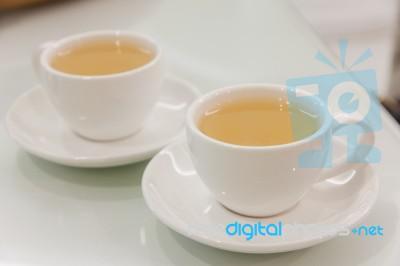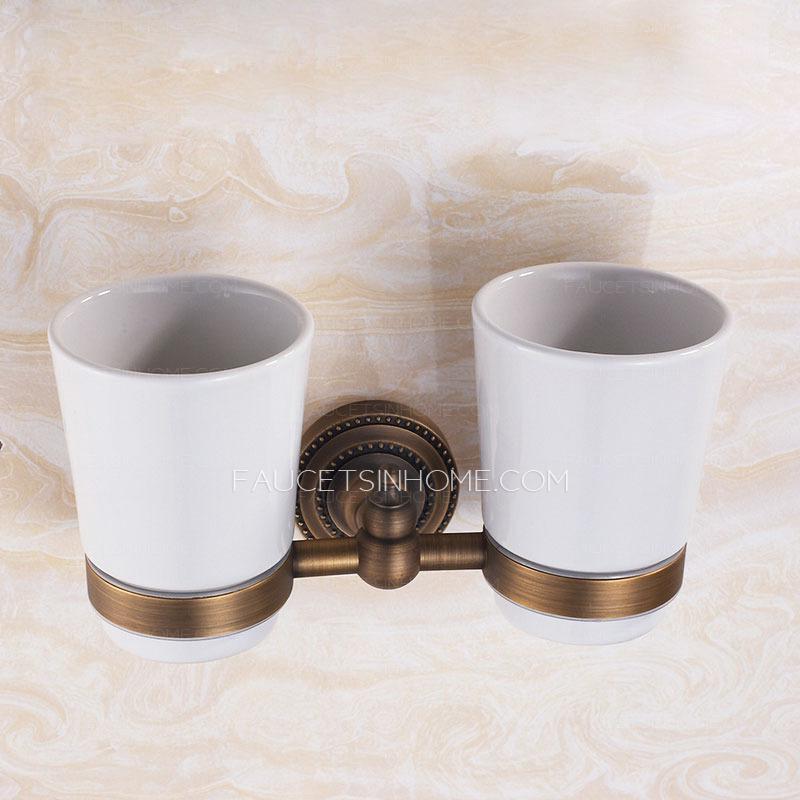The first image is the image on the left, the second image is the image on the right. Analyze the images presented: Is the assertion "There are two saucers in total, each holding a coffee cup." valid? Answer yes or no. Yes. The first image is the image on the left, the second image is the image on the right. Assess this claim about the two images: "An image shows one light-colored cup on top of a matching saucer.". Correct or not? Answer yes or no. No. 